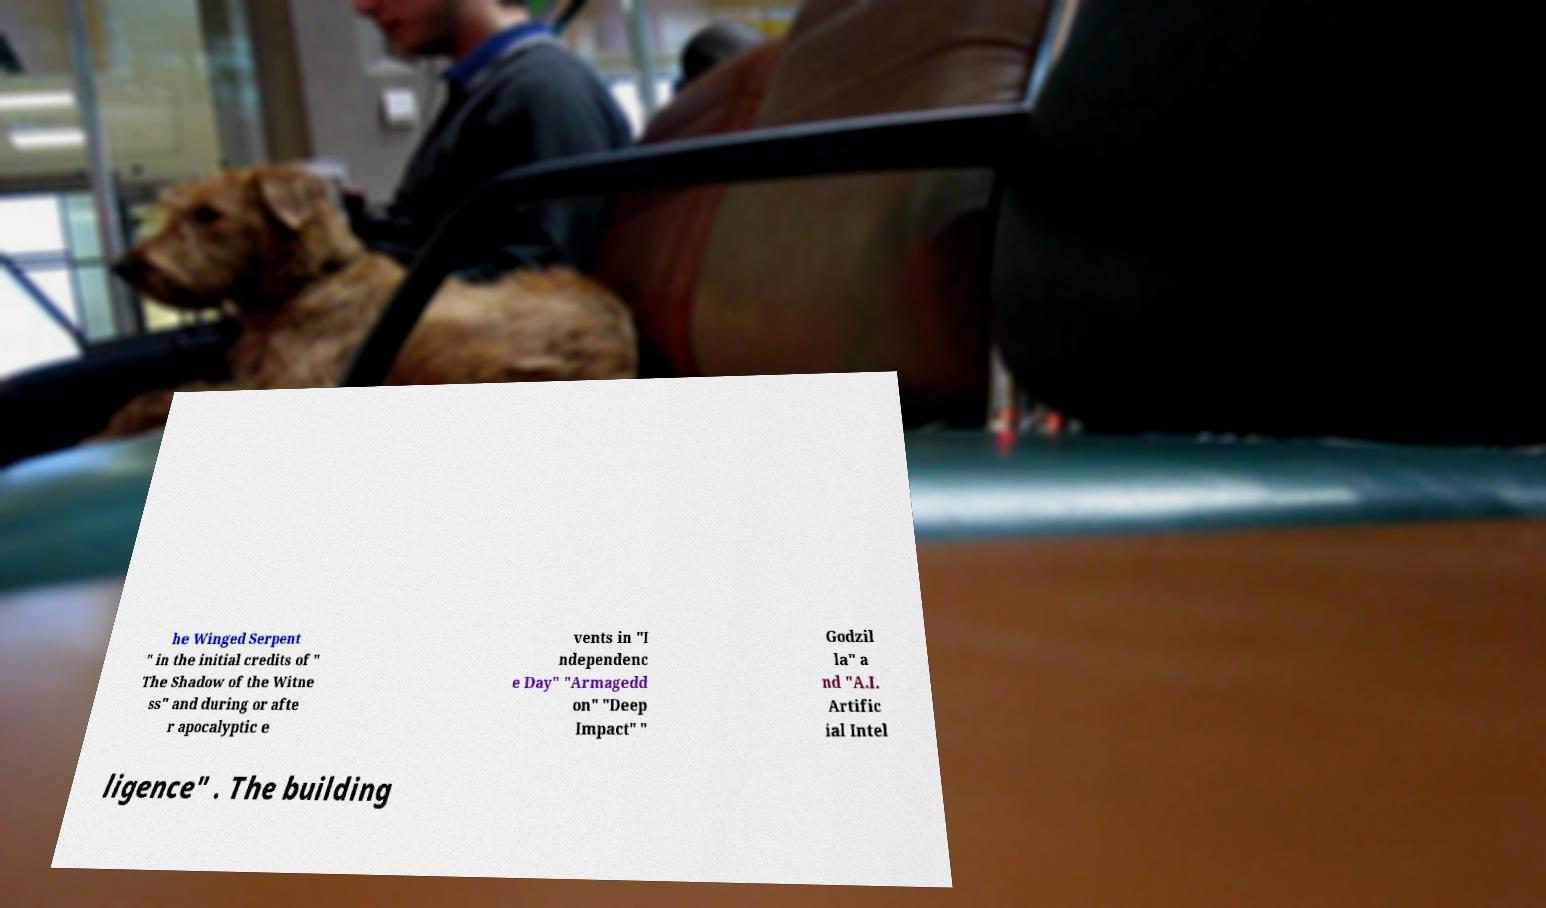Please read and relay the text visible in this image. What does it say? he Winged Serpent " in the initial credits of " The Shadow of the Witne ss" and during or afte r apocalyptic e vents in "I ndependenc e Day" "Armagedd on" "Deep Impact" " Godzil la" a nd "A.I. Artific ial Intel ligence" . The building 